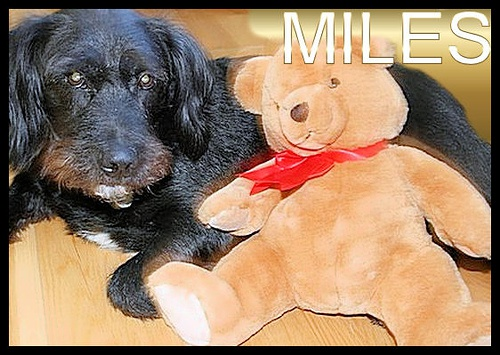Describe the objects in this image and their specific colors. I can see teddy bear in black, tan, and white tones and dog in black, gray, and darkgray tones in this image. 